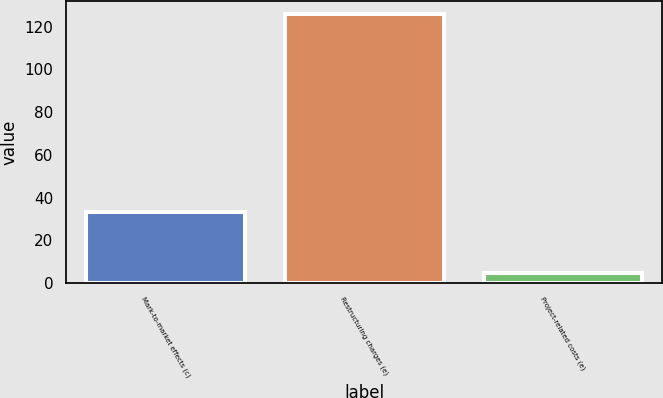Convert chart. <chart><loc_0><loc_0><loc_500><loc_500><bar_chart><fcel>Mark-to-market effects (c)<fcel>Restructuring charges (e)<fcel>Project-related costs (e)<nl><fcel>33.2<fcel>125.8<fcel>4.9<nl></chart> 